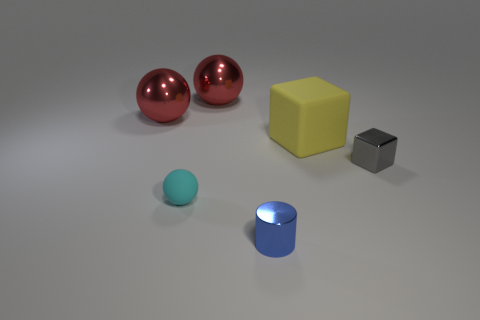What is the material of the large yellow cube behind the rubber thing that is on the left side of the large yellow matte cube?
Provide a succinct answer. Rubber. The matte block is what size?
Keep it short and to the point. Large. How many other metal things have the same size as the gray metal object?
Make the answer very short. 1. What number of red metallic things are the same shape as the tiny rubber object?
Offer a terse response. 2. Is the number of small gray blocks that are in front of the small cylinder the same as the number of big matte objects?
Your answer should be compact. No. What is the shape of the other rubber object that is the same size as the gray object?
Provide a short and direct response. Sphere. Are there any big yellow matte things that have the same shape as the gray thing?
Your response must be concise. Yes. There is a block on the left side of the tiny thing on the right side of the rubber block; are there any tiny rubber balls left of it?
Make the answer very short. Yes. Are there more tiny matte objects left of the gray shiny cube than large metal objects that are in front of the tiny shiny cylinder?
Your response must be concise. Yes. What is the material of the ball that is the same size as the metal block?
Your answer should be very brief. Rubber. 